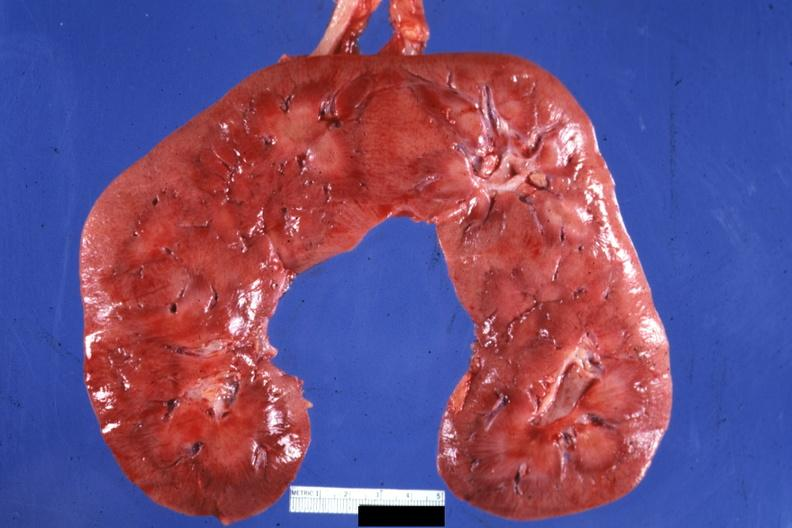does amyloidosis show frontal section quite good?
Answer the question using a single word or phrase. No 